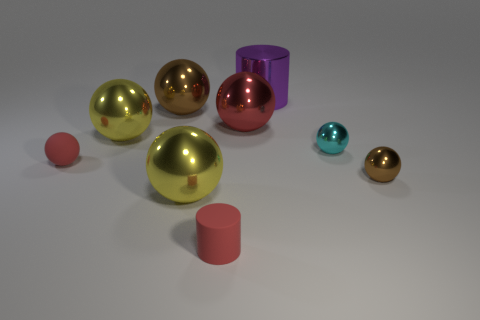Subtract all cyan spheres. How many spheres are left? 6 Subtract all red spheres. How many spheres are left? 5 Subtract all cyan balls. Subtract all gray cylinders. How many balls are left? 6 Add 1 purple objects. How many objects exist? 10 Subtract all spheres. How many objects are left? 2 Add 4 tiny yellow metallic spheres. How many tiny yellow metallic spheres exist? 4 Subtract 0 gray blocks. How many objects are left? 9 Subtract all brown things. Subtract all large purple cylinders. How many objects are left? 6 Add 5 small red matte objects. How many small red matte objects are left? 7 